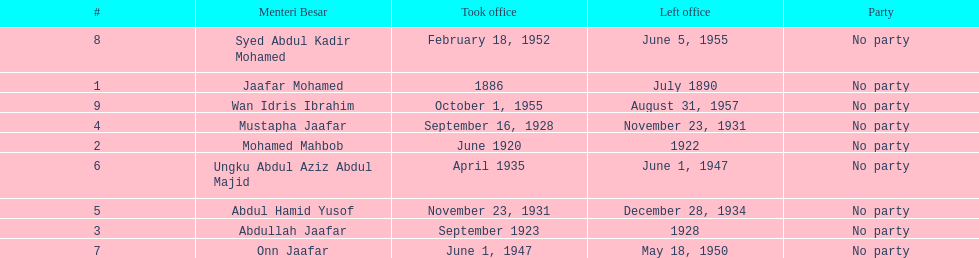Who took office after onn jaafar? Syed Abdul Kadir Mohamed. 